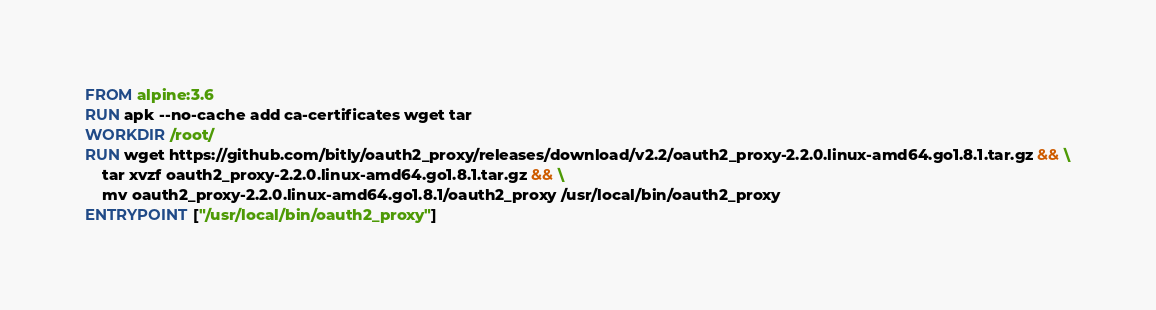<code> <loc_0><loc_0><loc_500><loc_500><_Dockerfile_>FROM alpine:3.6
RUN apk --no-cache add ca-certificates wget tar
WORKDIR /root/
RUN wget https://github.com/bitly/oauth2_proxy/releases/download/v2.2/oauth2_proxy-2.2.0.linux-amd64.go1.8.1.tar.gz && \
    tar xvzf oauth2_proxy-2.2.0.linux-amd64.go1.8.1.tar.gz && \
    mv oauth2_proxy-2.2.0.linux-amd64.go1.8.1/oauth2_proxy /usr/local/bin/oauth2_proxy
ENTRYPOINT ["/usr/local/bin/oauth2_proxy"]
</code> 